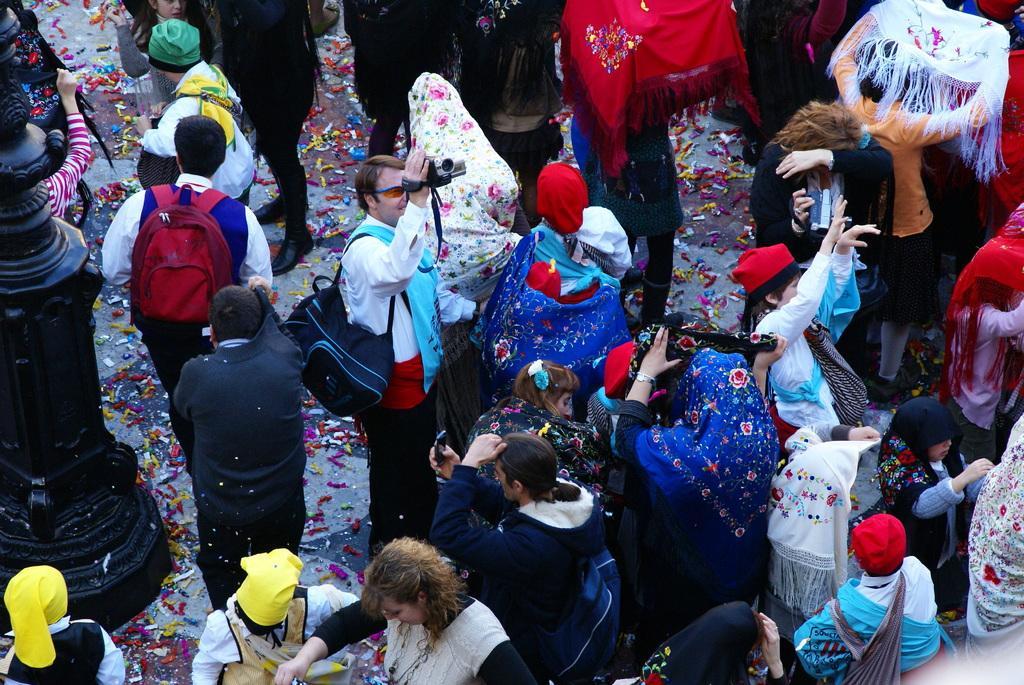Describe this image in one or two sentences. In this image I can see the group of people with different color dresses. I can see few people are wearing the bags and holding the cameras. To the left I can see the black color pole and one person holding the stroller. 